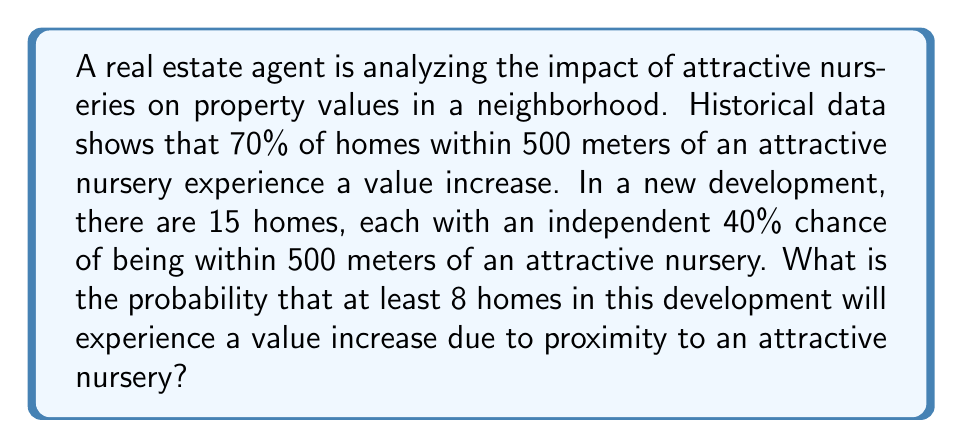Give your solution to this math problem. To solve this problem, we need to use the binomial probability distribution and the concept of cumulative probability. Let's break it down step by step:

1) First, we need to calculate the probability of a single home experiencing a value increase:
   $P(\text{value increase}) = P(\text{within 500m}) \times P(\text{increase | within 500m})$
   $= 0.40 \times 0.70 = 0.28$

2) Now, we can treat this as a binomial probability problem:
   - $n = 15$ (number of homes)
   - $p = 0.28$ (probability of success for each home)
   - We want the probability of 8 or more successes

3) The probability of at least 8 homes experiencing a value increase is equal to 1 minus the probability of 7 or fewer homes experiencing an increase:

   $P(X \geq 8) = 1 - P(X \leq 7)$

4) We can calculate this using the cumulative binomial probability function:

   $P(X \geq 8) = 1 - \sum_{k=0}^{7} \binom{15}{k} (0.28)^k (1-0.28)^{15-k}$

5) Using a calculator or statistical software to compute this sum:

   $P(X \geq 8) = 1 - 0.9427 = 0.0573$

Therefore, the probability that at least 8 homes in this development will experience a value increase due to proximity to an attractive nursery is approximately 0.0573 or 5.73%.
Answer: 0.0573 or 5.73% 